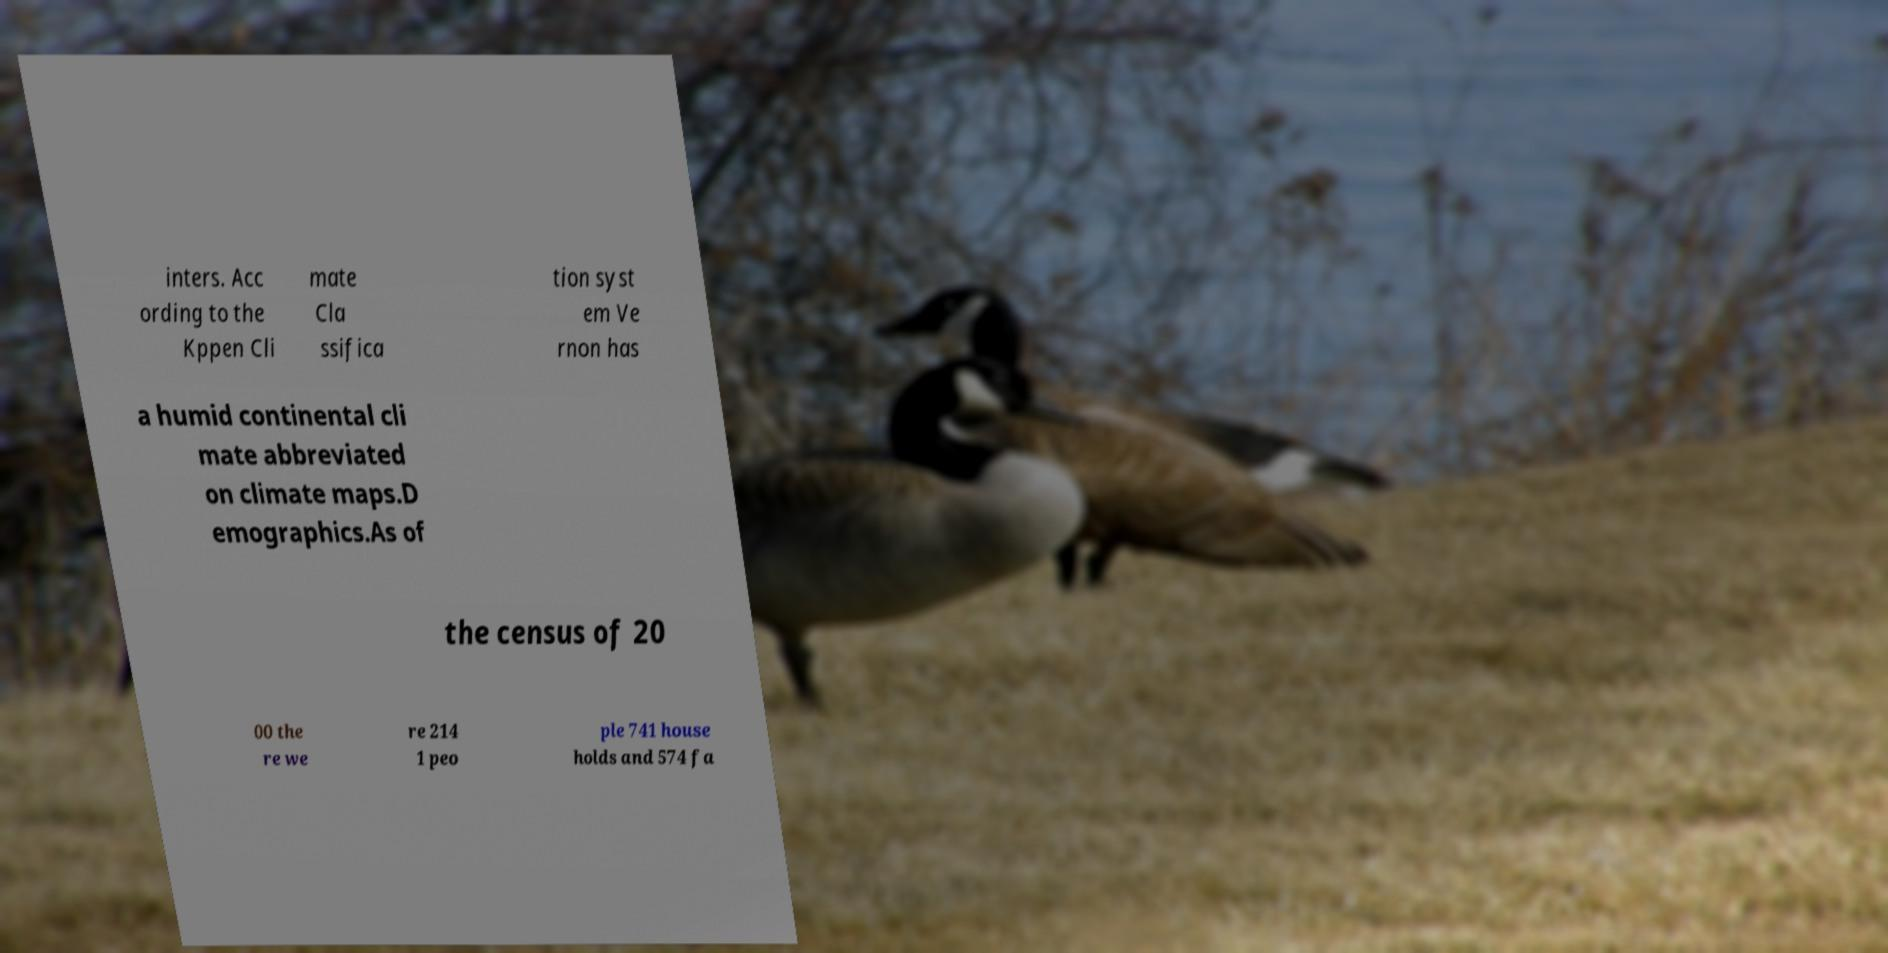What messages or text are displayed in this image? I need them in a readable, typed format. inters. Acc ording to the Kppen Cli mate Cla ssifica tion syst em Ve rnon has a humid continental cli mate abbreviated on climate maps.D emographics.As of the census of 20 00 the re we re 214 1 peo ple 741 house holds and 574 fa 